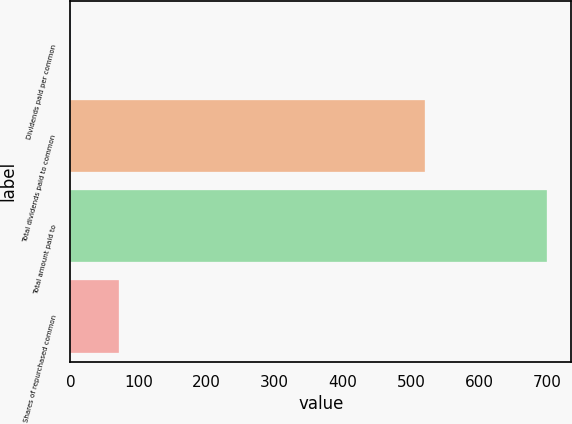Convert chart. <chart><loc_0><loc_0><loc_500><loc_500><bar_chart><fcel>Dividends paid per common<fcel>Total dividends paid to common<fcel>Total amount paid to<fcel>Shares of repurchased common<nl><fcel>1.38<fcel>521<fcel>700<fcel>71.24<nl></chart> 